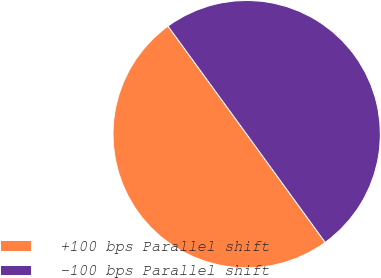<chart> <loc_0><loc_0><loc_500><loc_500><pie_chart><fcel>+100 bps Parallel shift<fcel>-100 bps Parallel shift<nl><fcel>49.98%<fcel>50.02%<nl></chart> 